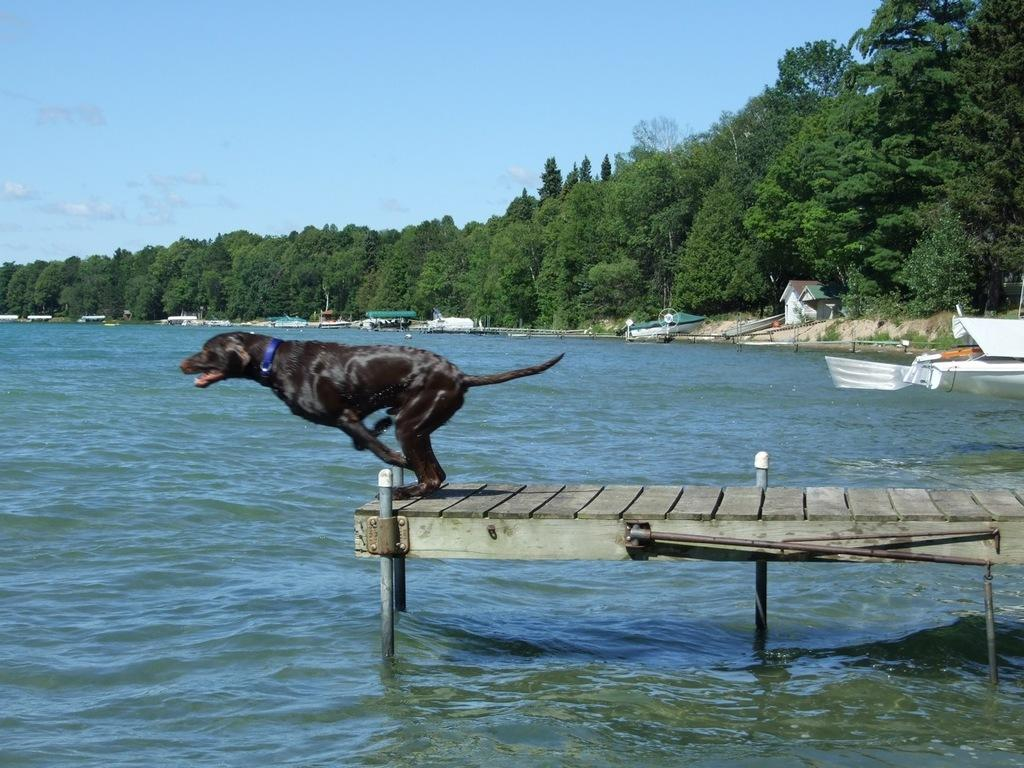What animal is present in the image? There is a dog in the image. Where is the dog located? The dog is on a wooden dock. What is the wooden dock situated on? The wooden dock is in the water. What can be seen in the middle of the image? There are trees in the middle of the image. What is visible at the top of the image? The sky is visible at the top of the image. How many toys can be seen in the image? There are no toys present in the image. What type of bird is perched on the dog's head in the image? There is no bird, specifically a robin, present in the image. 